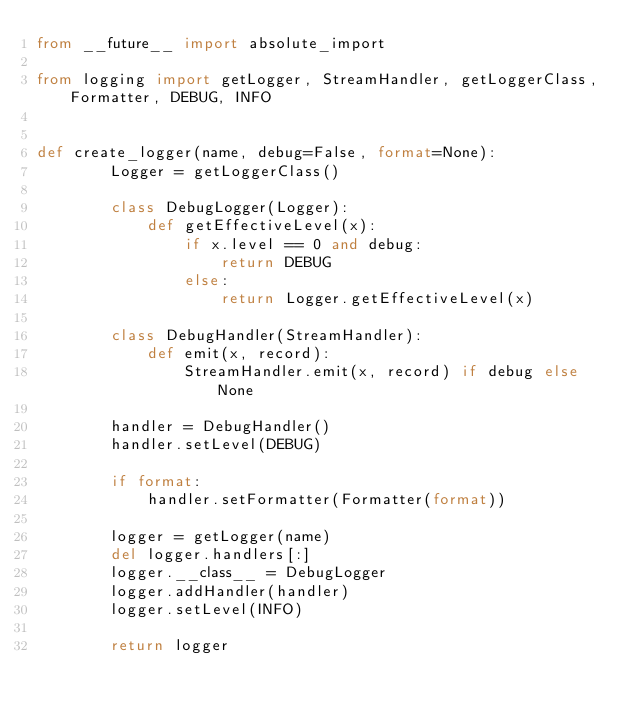Convert code to text. <code><loc_0><loc_0><loc_500><loc_500><_Python_>from __future__ import absolute_import

from logging import getLogger, StreamHandler, getLoggerClass, Formatter, DEBUG, INFO


def create_logger(name, debug=False, format=None):
        Logger = getLoggerClass()

        class DebugLogger(Logger):
            def getEffectiveLevel(x):
                if x.level == 0 and debug:
                    return DEBUG
                else:
                    return Logger.getEffectiveLevel(x)

        class DebugHandler(StreamHandler):
            def emit(x, record):
                StreamHandler.emit(x, record) if debug else None

        handler = DebugHandler()
        handler.setLevel(DEBUG)

        if format:
            handler.setFormatter(Formatter(format))

        logger = getLogger(name)
        del logger.handlers[:]
        logger.__class__ = DebugLogger
        logger.addHandler(handler)
        logger.setLevel(INFO)

        return logger
</code> 